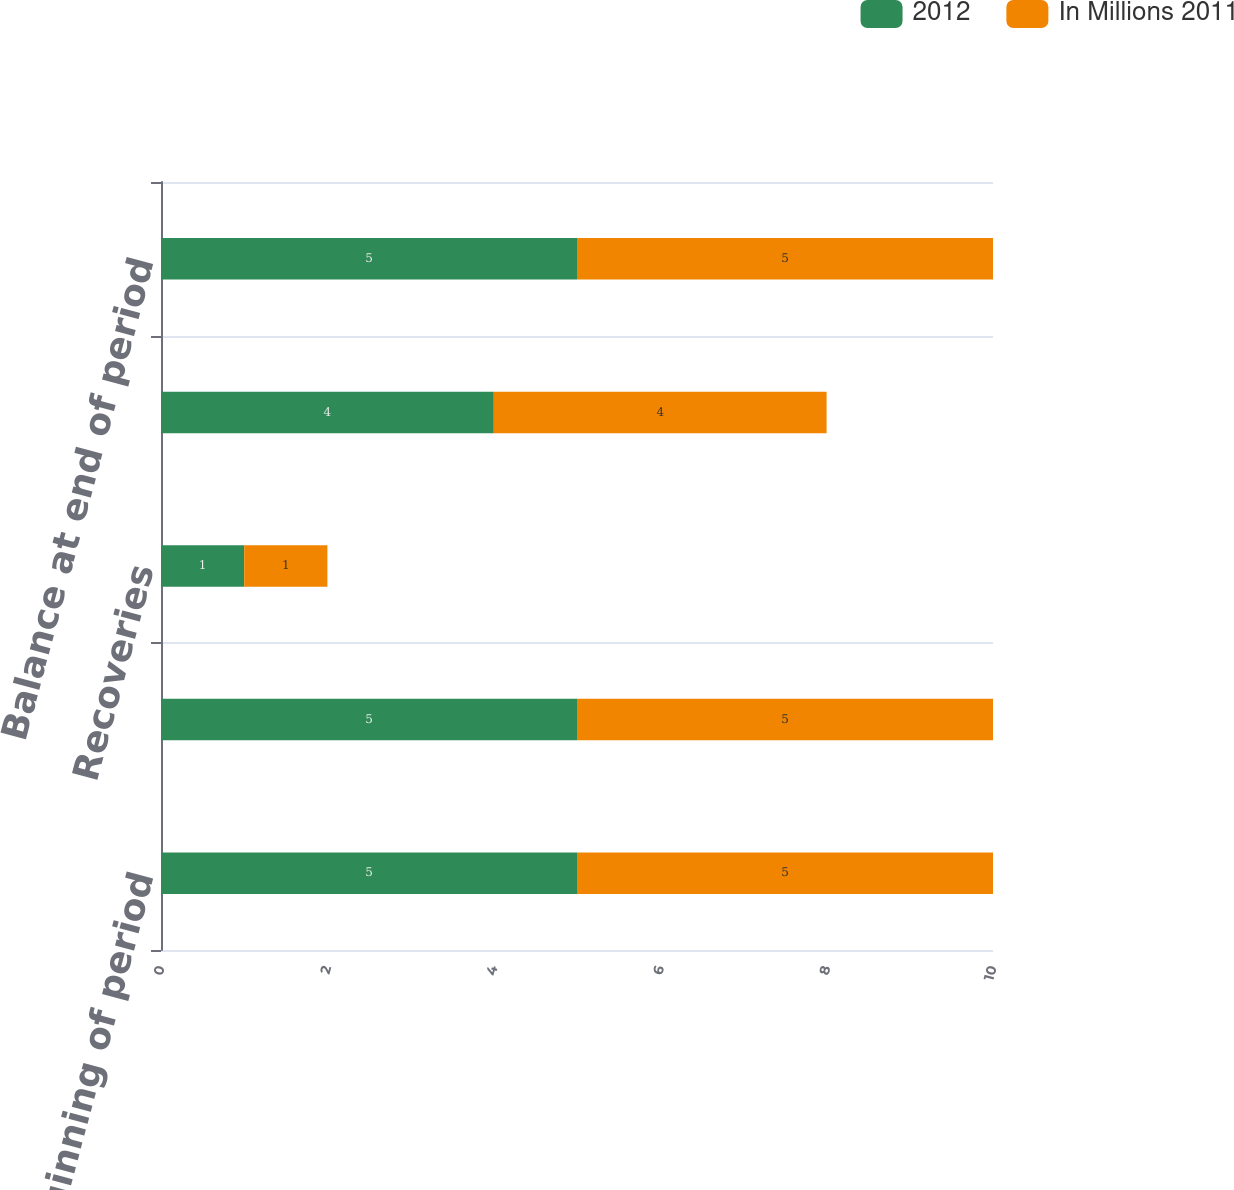Convert chart. <chart><loc_0><loc_0><loc_500><loc_500><stacked_bar_chart><ecel><fcel>Balance at beginning of period<fcel>Charge-offs<fcel>Recoveries<fcel>Provision for loan losses<fcel>Balance at end of period<nl><fcel>2012<fcel>5<fcel>5<fcel>1<fcel>4<fcel>5<nl><fcel>In Millions 2011<fcel>5<fcel>5<fcel>1<fcel>4<fcel>5<nl></chart> 